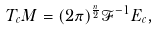<formula> <loc_0><loc_0><loc_500><loc_500>T _ { c } M = ( 2 \pi ) ^ { \frac { n } { 2 } } \mathcal { F } ^ { - 1 } E _ { c } ,</formula> 